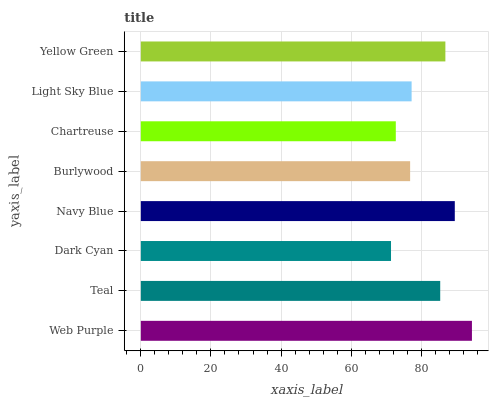Is Dark Cyan the minimum?
Answer yes or no. Yes. Is Web Purple the maximum?
Answer yes or no. Yes. Is Teal the minimum?
Answer yes or no. No. Is Teal the maximum?
Answer yes or no. No. Is Web Purple greater than Teal?
Answer yes or no. Yes. Is Teal less than Web Purple?
Answer yes or no. Yes. Is Teal greater than Web Purple?
Answer yes or no. No. Is Web Purple less than Teal?
Answer yes or no. No. Is Teal the high median?
Answer yes or no. Yes. Is Light Sky Blue the low median?
Answer yes or no. Yes. Is Light Sky Blue the high median?
Answer yes or no. No. Is Dark Cyan the low median?
Answer yes or no. No. 